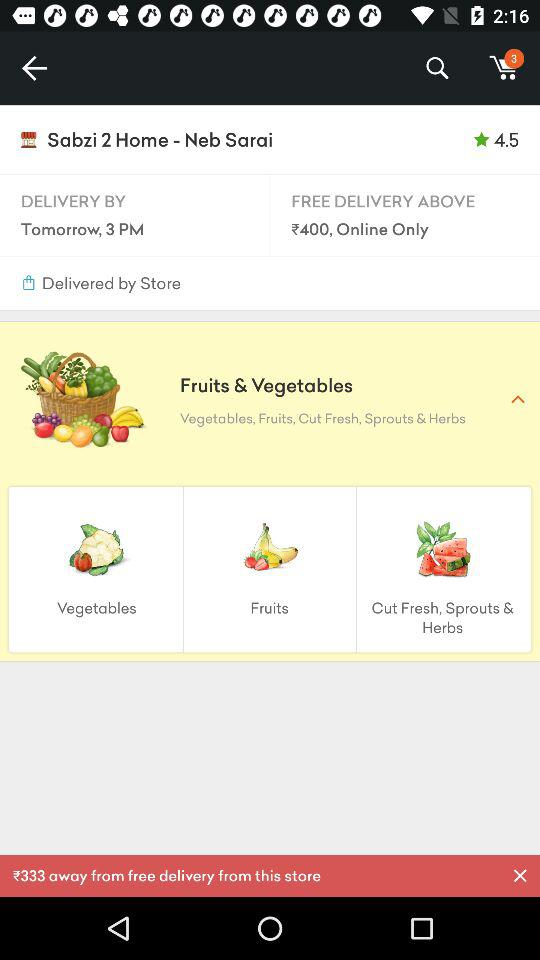How many fruits are available?
When the provided information is insufficient, respond with <no answer>. <no answer> 